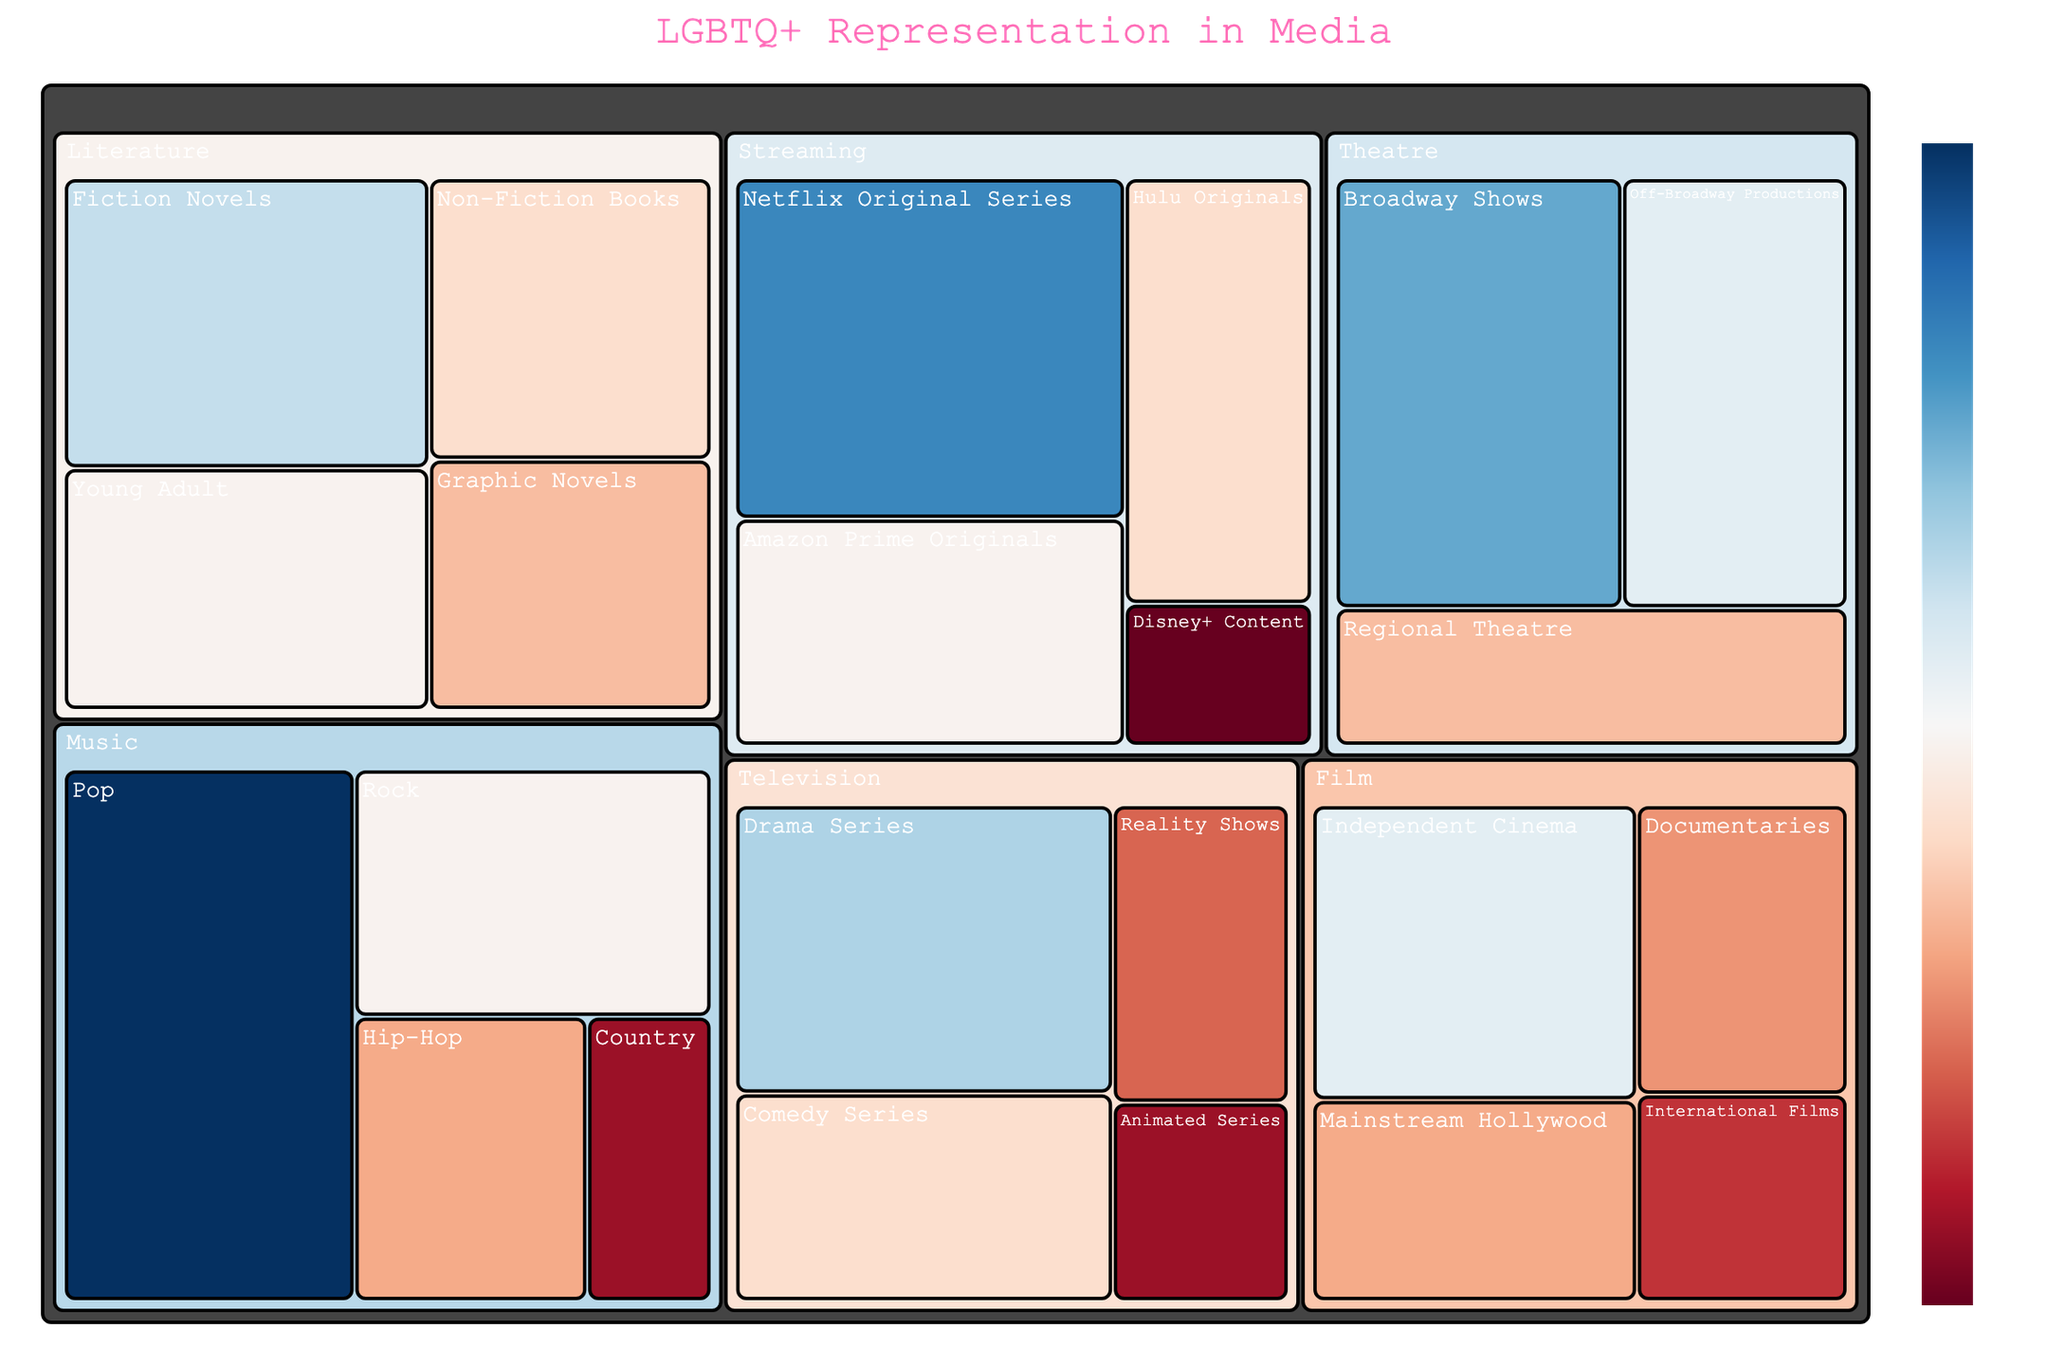What's the total representation value for television shows? Calculate the sum of values for all television subcategories: Drama Series (25) + Comedy Series (18) + Reality Shows (12) + Animated Series (8) = 63
Answer: 63 Which genre has the highest LGBTQ+ representation in music? Compare the values for all subcategories in music: Pop (35), Rock (20), Hip-Hop (15), Country (8). Pop has the highest value at 35.
Answer: Pop What's the difference in LGBTQ+ representation between Broadway shows and Off-Broadway productions in theatre? Subtract the value of Off-Broadway Productions (22) from Broadway Shows (28): 28 - 22 = 6
Answer: 6 How many subcategories does literature have? Count the number of subcategories listed under literature: Fiction Novels, Non-Fiction Books, Young Adult, Graphic Novels. There are 4 subcategories.
Answer: 4 Which streaming platform has the least LGBTQ+ representation? Compare values for all streaming subcategories: Netflix Original Series (30), Amazon Prime Originals (20), Hulu Originals (18), Disney+ Content (6). Disney+ Content has the lowest value at 6.
Answer: Disney+ Content What's the representation value for mainstream Hollywood films compared to international films? Mainstream Hollywood (15) and International Films (10). Mainstream Hollywood has a higher value at 15 compared to International Films at 10.
Answer: Mainstream Hollywood has higher Combine the LGBTQ+ representation in all film genres. Sum up all film subcategories: Mainstream Hollywood (15) + Independent Cinema (22) + International Films (10) + Documentaries (14) = 61
Answer: 61 Which subcategory in the figure has the highest LGBTQ+ representation? Find the highest value among all subcategories: Pop (35)
Answer: Pop What is the average LGBTQ+ representation across all theatre subcategories? Sum the values for Broadway Shows (28), Off-Broadway Productions (22), and Regional Theatre (16): 28 + 22 + 16 = 66. Divide by the number of theatre subcategories: 66/3 = 22
Answer: 22 What is the difference in LGBTQ+ representation between pop music and young adult literature? Subtract the value of Young Adult literature (20) from Pop music (35): 35 - 20 = 15
Answer: 15 